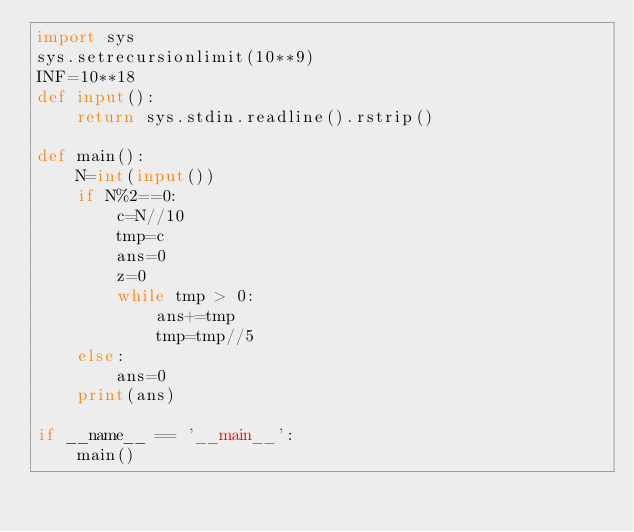Convert code to text. <code><loc_0><loc_0><loc_500><loc_500><_Python_>import sys
sys.setrecursionlimit(10**9)
INF=10**18
def input():
    return sys.stdin.readline().rstrip()

def main():
    N=int(input())
    if N%2==0:
        c=N//10
        tmp=c
        ans=0
        z=0
        while tmp > 0:
            ans+=tmp
            tmp=tmp//5
    else:
        ans=0
    print(ans)

if __name__ == '__main__':
    main()
</code> 